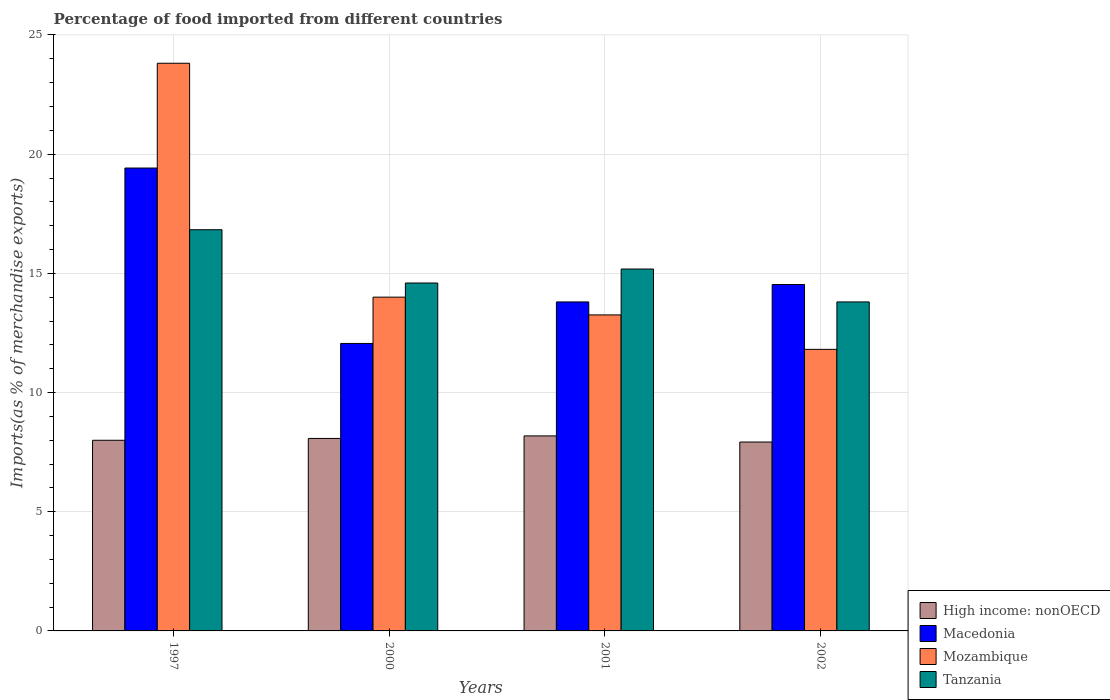How many different coloured bars are there?
Your response must be concise. 4. How many bars are there on the 4th tick from the left?
Provide a succinct answer. 4. How many bars are there on the 1st tick from the right?
Give a very brief answer. 4. In how many cases, is the number of bars for a given year not equal to the number of legend labels?
Keep it short and to the point. 0. What is the percentage of imports to different countries in Tanzania in 2000?
Ensure brevity in your answer.  14.6. Across all years, what is the maximum percentage of imports to different countries in Macedonia?
Your answer should be very brief. 19.42. Across all years, what is the minimum percentage of imports to different countries in Mozambique?
Provide a succinct answer. 11.81. In which year was the percentage of imports to different countries in Tanzania minimum?
Keep it short and to the point. 2002. What is the total percentage of imports to different countries in Tanzania in the graph?
Make the answer very short. 60.41. What is the difference between the percentage of imports to different countries in Tanzania in 2000 and that in 2002?
Make the answer very short. 0.79. What is the difference between the percentage of imports to different countries in Mozambique in 1997 and the percentage of imports to different countries in High income: nonOECD in 2001?
Your answer should be compact. 15.63. What is the average percentage of imports to different countries in Mozambique per year?
Offer a terse response. 15.72. In the year 1997, what is the difference between the percentage of imports to different countries in Macedonia and percentage of imports to different countries in High income: nonOECD?
Ensure brevity in your answer.  11.42. What is the ratio of the percentage of imports to different countries in Tanzania in 2001 to that in 2002?
Ensure brevity in your answer.  1.1. Is the difference between the percentage of imports to different countries in Macedonia in 2000 and 2001 greater than the difference between the percentage of imports to different countries in High income: nonOECD in 2000 and 2001?
Your answer should be very brief. No. What is the difference between the highest and the second highest percentage of imports to different countries in Macedonia?
Your answer should be very brief. 4.89. What is the difference between the highest and the lowest percentage of imports to different countries in Tanzania?
Your answer should be compact. 3.03. In how many years, is the percentage of imports to different countries in High income: nonOECD greater than the average percentage of imports to different countries in High income: nonOECD taken over all years?
Ensure brevity in your answer.  2. Is the sum of the percentage of imports to different countries in Tanzania in 1997 and 2000 greater than the maximum percentage of imports to different countries in Macedonia across all years?
Offer a terse response. Yes. What does the 2nd bar from the left in 2001 represents?
Offer a terse response. Macedonia. What does the 2nd bar from the right in 1997 represents?
Offer a very short reply. Mozambique. Is it the case that in every year, the sum of the percentage of imports to different countries in Tanzania and percentage of imports to different countries in Mozambique is greater than the percentage of imports to different countries in Macedonia?
Offer a very short reply. Yes. How many bars are there?
Give a very brief answer. 16. Are all the bars in the graph horizontal?
Your response must be concise. No. What is the difference between two consecutive major ticks on the Y-axis?
Offer a terse response. 5. Are the values on the major ticks of Y-axis written in scientific E-notation?
Provide a short and direct response. No. Does the graph contain any zero values?
Provide a short and direct response. No. Does the graph contain grids?
Offer a very short reply. Yes. Where does the legend appear in the graph?
Your response must be concise. Bottom right. How many legend labels are there?
Ensure brevity in your answer.  4. What is the title of the graph?
Offer a very short reply. Percentage of food imported from different countries. Does "New Zealand" appear as one of the legend labels in the graph?
Provide a short and direct response. No. What is the label or title of the X-axis?
Give a very brief answer. Years. What is the label or title of the Y-axis?
Offer a terse response. Imports(as % of merchandise exports). What is the Imports(as % of merchandise exports) of High income: nonOECD in 1997?
Give a very brief answer. 8. What is the Imports(as % of merchandise exports) in Macedonia in 1997?
Provide a succinct answer. 19.42. What is the Imports(as % of merchandise exports) of Mozambique in 1997?
Your answer should be very brief. 23.81. What is the Imports(as % of merchandise exports) in Tanzania in 1997?
Provide a short and direct response. 16.83. What is the Imports(as % of merchandise exports) of High income: nonOECD in 2000?
Keep it short and to the point. 8.07. What is the Imports(as % of merchandise exports) of Macedonia in 2000?
Provide a succinct answer. 12.06. What is the Imports(as % of merchandise exports) of Mozambique in 2000?
Offer a very short reply. 14. What is the Imports(as % of merchandise exports) of Tanzania in 2000?
Give a very brief answer. 14.6. What is the Imports(as % of merchandise exports) of High income: nonOECD in 2001?
Keep it short and to the point. 8.18. What is the Imports(as % of merchandise exports) of Macedonia in 2001?
Give a very brief answer. 13.8. What is the Imports(as % of merchandise exports) of Mozambique in 2001?
Provide a short and direct response. 13.26. What is the Imports(as % of merchandise exports) in Tanzania in 2001?
Offer a terse response. 15.18. What is the Imports(as % of merchandise exports) in High income: nonOECD in 2002?
Offer a very short reply. 7.92. What is the Imports(as % of merchandise exports) in Macedonia in 2002?
Offer a very short reply. 14.53. What is the Imports(as % of merchandise exports) in Mozambique in 2002?
Provide a short and direct response. 11.81. What is the Imports(as % of merchandise exports) of Tanzania in 2002?
Your answer should be very brief. 13.8. Across all years, what is the maximum Imports(as % of merchandise exports) in High income: nonOECD?
Make the answer very short. 8.18. Across all years, what is the maximum Imports(as % of merchandise exports) of Macedonia?
Keep it short and to the point. 19.42. Across all years, what is the maximum Imports(as % of merchandise exports) in Mozambique?
Give a very brief answer. 23.81. Across all years, what is the maximum Imports(as % of merchandise exports) of Tanzania?
Provide a succinct answer. 16.83. Across all years, what is the minimum Imports(as % of merchandise exports) in High income: nonOECD?
Make the answer very short. 7.92. Across all years, what is the minimum Imports(as % of merchandise exports) in Macedonia?
Provide a short and direct response. 12.06. Across all years, what is the minimum Imports(as % of merchandise exports) in Mozambique?
Make the answer very short. 11.81. Across all years, what is the minimum Imports(as % of merchandise exports) in Tanzania?
Make the answer very short. 13.8. What is the total Imports(as % of merchandise exports) in High income: nonOECD in the graph?
Your answer should be compact. 32.18. What is the total Imports(as % of merchandise exports) of Macedonia in the graph?
Your response must be concise. 59.81. What is the total Imports(as % of merchandise exports) in Mozambique in the graph?
Your response must be concise. 62.88. What is the total Imports(as % of merchandise exports) of Tanzania in the graph?
Give a very brief answer. 60.41. What is the difference between the Imports(as % of merchandise exports) in High income: nonOECD in 1997 and that in 2000?
Ensure brevity in your answer.  -0.08. What is the difference between the Imports(as % of merchandise exports) of Macedonia in 1997 and that in 2000?
Your answer should be very brief. 7.36. What is the difference between the Imports(as % of merchandise exports) of Mozambique in 1997 and that in 2000?
Provide a succinct answer. 9.81. What is the difference between the Imports(as % of merchandise exports) in Tanzania in 1997 and that in 2000?
Provide a short and direct response. 2.24. What is the difference between the Imports(as % of merchandise exports) of High income: nonOECD in 1997 and that in 2001?
Offer a terse response. -0.18. What is the difference between the Imports(as % of merchandise exports) in Macedonia in 1997 and that in 2001?
Provide a short and direct response. 5.62. What is the difference between the Imports(as % of merchandise exports) in Mozambique in 1997 and that in 2001?
Provide a succinct answer. 10.56. What is the difference between the Imports(as % of merchandise exports) in Tanzania in 1997 and that in 2001?
Give a very brief answer. 1.65. What is the difference between the Imports(as % of merchandise exports) of High income: nonOECD in 1997 and that in 2002?
Your answer should be compact. 0.07. What is the difference between the Imports(as % of merchandise exports) of Macedonia in 1997 and that in 2002?
Keep it short and to the point. 4.89. What is the difference between the Imports(as % of merchandise exports) in Mozambique in 1997 and that in 2002?
Your response must be concise. 12. What is the difference between the Imports(as % of merchandise exports) of Tanzania in 1997 and that in 2002?
Your answer should be compact. 3.03. What is the difference between the Imports(as % of merchandise exports) of High income: nonOECD in 2000 and that in 2001?
Make the answer very short. -0.11. What is the difference between the Imports(as % of merchandise exports) of Macedonia in 2000 and that in 2001?
Your answer should be compact. -1.74. What is the difference between the Imports(as % of merchandise exports) in Mozambique in 2000 and that in 2001?
Provide a succinct answer. 0.75. What is the difference between the Imports(as % of merchandise exports) of Tanzania in 2000 and that in 2001?
Your response must be concise. -0.59. What is the difference between the Imports(as % of merchandise exports) in High income: nonOECD in 2000 and that in 2002?
Your response must be concise. 0.15. What is the difference between the Imports(as % of merchandise exports) of Macedonia in 2000 and that in 2002?
Provide a short and direct response. -2.47. What is the difference between the Imports(as % of merchandise exports) of Mozambique in 2000 and that in 2002?
Keep it short and to the point. 2.19. What is the difference between the Imports(as % of merchandise exports) of Tanzania in 2000 and that in 2002?
Your answer should be very brief. 0.79. What is the difference between the Imports(as % of merchandise exports) in High income: nonOECD in 2001 and that in 2002?
Provide a succinct answer. 0.26. What is the difference between the Imports(as % of merchandise exports) of Macedonia in 2001 and that in 2002?
Your response must be concise. -0.73. What is the difference between the Imports(as % of merchandise exports) in Mozambique in 2001 and that in 2002?
Your answer should be compact. 1.44. What is the difference between the Imports(as % of merchandise exports) of Tanzania in 2001 and that in 2002?
Your answer should be very brief. 1.38. What is the difference between the Imports(as % of merchandise exports) in High income: nonOECD in 1997 and the Imports(as % of merchandise exports) in Macedonia in 2000?
Offer a very short reply. -4.06. What is the difference between the Imports(as % of merchandise exports) of High income: nonOECD in 1997 and the Imports(as % of merchandise exports) of Mozambique in 2000?
Keep it short and to the point. -6. What is the difference between the Imports(as % of merchandise exports) of High income: nonOECD in 1997 and the Imports(as % of merchandise exports) of Tanzania in 2000?
Provide a short and direct response. -6.6. What is the difference between the Imports(as % of merchandise exports) in Macedonia in 1997 and the Imports(as % of merchandise exports) in Mozambique in 2000?
Make the answer very short. 5.42. What is the difference between the Imports(as % of merchandise exports) in Macedonia in 1997 and the Imports(as % of merchandise exports) in Tanzania in 2000?
Keep it short and to the point. 4.82. What is the difference between the Imports(as % of merchandise exports) of Mozambique in 1997 and the Imports(as % of merchandise exports) of Tanzania in 2000?
Offer a very short reply. 9.22. What is the difference between the Imports(as % of merchandise exports) of High income: nonOECD in 1997 and the Imports(as % of merchandise exports) of Macedonia in 2001?
Your answer should be very brief. -5.8. What is the difference between the Imports(as % of merchandise exports) in High income: nonOECD in 1997 and the Imports(as % of merchandise exports) in Mozambique in 2001?
Ensure brevity in your answer.  -5.26. What is the difference between the Imports(as % of merchandise exports) of High income: nonOECD in 1997 and the Imports(as % of merchandise exports) of Tanzania in 2001?
Give a very brief answer. -7.18. What is the difference between the Imports(as % of merchandise exports) of Macedonia in 1997 and the Imports(as % of merchandise exports) of Mozambique in 2001?
Keep it short and to the point. 6.16. What is the difference between the Imports(as % of merchandise exports) in Macedonia in 1997 and the Imports(as % of merchandise exports) in Tanzania in 2001?
Your answer should be very brief. 4.24. What is the difference between the Imports(as % of merchandise exports) of Mozambique in 1997 and the Imports(as % of merchandise exports) of Tanzania in 2001?
Make the answer very short. 8.63. What is the difference between the Imports(as % of merchandise exports) of High income: nonOECD in 1997 and the Imports(as % of merchandise exports) of Macedonia in 2002?
Your answer should be very brief. -6.53. What is the difference between the Imports(as % of merchandise exports) in High income: nonOECD in 1997 and the Imports(as % of merchandise exports) in Mozambique in 2002?
Your answer should be compact. -3.81. What is the difference between the Imports(as % of merchandise exports) of High income: nonOECD in 1997 and the Imports(as % of merchandise exports) of Tanzania in 2002?
Ensure brevity in your answer.  -5.8. What is the difference between the Imports(as % of merchandise exports) of Macedonia in 1997 and the Imports(as % of merchandise exports) of Mozambique in 2002?
Your answer should be very brief. 7.61. What is the difference between the Imports(as % of merchandise exports) of Macedonia in 1997 and the Imports(as % of merchandise exports) of Tanzania in 2002?
Make the answer very short. 5.62. What is the difference between the Imports(as % of merchandise exports) of Mozambique in 1997 and the Imports(as % of merchandise exports) of Tanzania in 2002?
Provide a succinct answer. 10.01. What is the difference between the Imports(as % of merchandise exports) in High income: nonOECD in 2000 and the Imports(as % of merchandise exports) in Macedonia in 2001?
Your answer should be compact. -5.73. What is the difference between the Imports(as % of merchandise exports) of High income: nonOECD in 2000 and the Imports(as % of merchandise exports) of Mozambique in 2001?
Provide a short and direct response. -5.18. What is the difference between the Imports(as % of merchandise exports) of High income: nonOECD in 2000 and the Imports(as % of merchandise exports) of Tanzania in 2001?
Keep it short and to the point. -7.11. What is the difference between the Imports(as % of merchandise exports) of Macedonia in 2000 and the Imports(as % of merchandise exports) of Mozambique in 2001?
Your answer should be very brief. -1.2. What is the difference between the Imports(as % of merchandise exports) of Macedonia in 2000 and the Imports(as % of merchandise exports) of Tanzania in 2001?
Make the answer very short. -3.12. What is the difference between the Imports(as % of merchandise exports) of Mozambique in 2000 and the Imports(as % of merchandise exports) of Tanzania in 2001?
Your answer should be very brief. -1.18. What is the difference between the Imports(as % of merchandise exports) in High income: nonOECD in 2000 and the Imports(as % of merchandise exports) in Macedonia in 2002?
Offer a very short reply. -6.46. What is the difference between the Imports(as % of merchandise exports) of High income: nonOECD in 2000 and the Imports(as % of merchandise exports) of Mozambique in 2002?
Provide a short and direct response. -3.74. What is the difference between the Imports(as % of merchandise exports) in High income: nonOECD in 2000 and the Imports(as % of merchandise exports) in Tanzania in 2002?
Your response must be concise. -5.73. What is the difference between the Imports(as % of merchandise exports) of Macedonia in 2000 and the Imports(as % of merchandise exports) of Mozambique in 2002?
Provide a succinct answer. 0.25. What is the difference between the Imports(as % of merchandise exports) in Macedonia in 2000 and the Imports(as % of merchandise exports) in Tanzania in 2002?
Your answer should be compact. -1.74. What is the difference between the Imports(as % of merchandise exports) of Mozambique in 2000 and the Imports(as % of merchandise exports) of Tanzania in 2002?
Offer a very short reply. 0.2. What is the difference between the Imports(as % of merchandise exports) in High income: nonOECD in 2001 and the Imports(as % of merchandise exports) in Macedonia in 2002?
Give a very brief answer. -6.35. What is the difference between the Imports(as % of merchandise exports) of High income: nonOECD in 2001 and the Imports(as % of merchandise exports) of Mozambique in 2002?
Ensure brevity in your answer.  -3.63. What is the difference between the Imports(as % of merchandise exports) of High income: nonOECD in 2001 and the Imports(as % of merchandise exports) of Tanzania in 2002?
Give a very brief answer. -5.62. What is the difference between the Imports(as % of merchandise exports) in Macedonia in 2001 and the Imports(as % of merchandise exports) in Mozambique in 2002?
Ensure brevity in your answer.  1.99. What is the difference between the Imports(as % of merchandise exports) in Macedonia in 2001 and the Imports(as % of merchandise exports) in Tanzania in 2002?
Your response must be concise. -0. What is the difference between the Imports(as % of merchandise exports) of Mozambique in 2001 and the Imports(as % of merchandise exports) of Tanzania in 2002?
Provide a short and direct response. -0.55. What is the average Imports(as % of merchandise exports) in High income: nonOECD per year?
Give a very brief answer. 8.04. What is the average Imports(as % of merchandise exports) of Macedonia per year?
Offer a very short reply. 14.95. What is the average Imports(as % of merchandise exports) of Mozambique per year?
Offer a very short reply. 15.72. What is the average Imports(as % of merchandise exports) in Tanzania per year?
Keep it short and to the point. 15.1. In the year 1997, what is the difference between the Imports(as % of merchandise exports) in High income: nonOECD and Imports(as % of merchandise exports) in Macedonia?
Give a very brief answer. -11.42. In the year 1997, what is the difference between the Imports(as % of merchandise exports) of High income: nonOECD and Imports(as % of merchandise exports) of Mozambique?
Offer a very short reply. -15.82. In the year 1997, what is the difference between the Imports(as % of merchandise exports) in High income: nonOECD and Imports(as % of merchandise exports) in Tanzania?
Provide a succinct answer. -8.83. In the year 1997, what is the difference between the Imports(as % of merchandise exports) of Macedonia and Imports(as % of merchandise exports) of Mozambique?
Your answer should be compact. -4.4. In the year 1997, what is the difference between the Imports(as % of merchandise exports) of Macedonia and Imports(as % of merchandise exports) of Tanzania?
Your response must be concise. 2.59. In the year 1997, what is the difference between the Imports(as % of merchandise exports) in Mozambique and Imports(as % of merchandise exports) in Tanzania?
Provide a short and direct response. 6.98. In the year 2000, what is the difference between the Imports(as % of merchandise exports) of High income: nonOECD and Imports(as % of merchandise exports) of Macedonia?
Offer a terse response. -3.98. In the year 2000, what is the difference between the Imports(as % of merchandise exports) in High income: nonOECD and Imports(as % of merchandise exports) in Mozambique?
Provide a short and direct response. -5.93. In the year 2000, what is the difference between the Imports(as % of merchandise exports) in High income: nonOECD and Imports(as % of merchandise exports) in Tanzania?
Provide a succinct answer. -6.52. In the year 2000, what is the difference between the Imports(as % of merchandise exports) in Macedonia and Imports(as % of merchandise exports) in Mozambique?
Give a very brief answer. -1.94. In the year 2000, what is the difference between the Imports(as % of merchandise exports) of Macedonia and Imports(as % of merchandise exports) of Tanzania?
Provide a succinct answer. -2.54. In the year 2000, what is the difference between the Imports(as % of merchandise exports) of Mozambique and Imports(as % of merchandise exports) of Tanzania?
Keep it short and to the point. -0.59. In the year 2001, what is the difference between the Imports(as % of merchandise exports) of High income: nonOECD and Imports(as % of merchandise exports) of Macedonia?
Offer a very short reply. -5.62. In the year 2001, what is the difference between the Imports(as % of merchandise exports) in High income: nonOECD and Imports(as % of merchandise exports) in Mozambique?
Give a very brief answer. -5.08. In the year 2001, what is the difference between the Imports(as % of merchandise exports) of High income: nonOECD and Imports(as % of merchandise exports) of Tanzania?
Keep it short and to the point. -7. In the year 2001, what is the difference between the Imports(as % of merchandise exports) of Macedonia and Imports(as % of merchandise exports) of Mozambique?
Offer a terse response. 0.54. In the year 2001, what is the difference between the Imports(as % of merchandise exports) of Macedonia and Imports(as % of merchandise exports) of Tanzania?
Offer a very short reply. -1.38. In the year 2001, what is the difference between the Imports(as % of merchandise exports) of Mozambique and Imports(as % of merchandise exports) of Tanzania?
Make the answer very short. -1.93. In the year 2002, what is the difference between the Imports(as % of merchandise exports) of High income: nonOECD and Imports(as % of merchandise exports) of Macedonia?
Keep it short and to the point. -6.61. In the year 2002, what is the difference between the Imports(as % of merchandise exports) in High income: nonOECD and Imports(as % of merchandise exports) in Mozambique?
Provide a short and direct response. -3.89. In the year 2002, what is the difference between the Imports(as % of merchandise exports) of High income: nonOECD and Imports(as % of merchandise exports) of Tanzania?
Provide a succinct answer. -5.88. In the year 2002, what is the difference between the Imports(as % of merchandise exports) in Macedonia and Imports(as % of merchandise exports) in Mozambique?
Your answer should be very brief. 2.72. In the year 2002, what is the difference between the Imports(as % of merchandise exports) in Macedonia and Imports(as % of merchandise exports) in Tanzania?
Ensure brevity in your answer.  0.73. In the year 2002, what is the difference between the Imports(as % of merchandise exports) in Mozambique and Imports(as % of merchandise exports) in Tanzania?
Give a very brief answer. -1.99. What is the ratio of the Imports(as % of merchandise exports) of Macedonia in 1997 to that in 2000?
Your response must be concise. 1.61. What is the ratio of the Imports(as % of merchandise exports) in Mozambique in 1997 to that in 2000?
Provide a succinct answer. 1.7. What is the ratio of the Imports(as % of merchandise exports) of Tanzania in 1997 to that in 2000?
Your answer should be very brief. 1.15. What is the ratio of the Imports(as % of merchandise exports) of High income: nonOECD in 1997 to that in 2001?
Give a very brief answer. 0.98. What is the ratio of the Imports(as % of merchandise exports) of Macedonia in 1997 to that in 2001?
Offer a very short reply. 1.41. What is the ratio of the Imports(as % of merchandise exports) of Mozambique in 1997 to that in 2001?
Your response must be concise. 1.8. What is the ratio of the Imports(as % of merchandise exports) in Tanzania in 1997 to that in 2001?
Offer a terse response. 1.11. What is the ratio of the Imports(as % of merchandise exports) of High income: nonOECD in 1997 to that in 2002?
Your response must be concise. 1.01. What is the ratio of the Imports(as % of merchandise exports) of Macedonia in 1997 to that in 2002?
Make the answer very short. 1.34. What is the ratio of the Imports(as % of merchandise exports) in Mozambique in 1997 to that in 2002?
Make the answer very short. 2.02. What is the ratio of the Imports(as % of merchandise exports) of Tanzania in 1997 to that in 2002?
Your answer should be compact. 1.22. What is the ratio of the Imports(as % of merchandise exports) of High income: nonOECD in 2000 to that in 2001?
Make the answer very short. 0.99. What is the ratio of the Imports(as % of merchandise exports) of Macedonia in 2000 to that in 2001?
Ensure brevity in your answer.  0.87. What is the ratio of the Imports(as % of merchandise exports) of Mozambique in 2000 to that in 2001?
Your answer should be compact. 1.06. What is the ratio of the Imports(as % of merchandise exports) of Tanzania in 2000 to that in 2001?
Provide a succinct answer. 0.96. What is the ratio of the Imports(as % of merchandise exports) in High income: nonOECD in 2000 to that in 2002?
Ensure brevity in your answer.  1.02. What is the ratio of the Imports(as % of merchandise exports) of Macedonia in 2000 to that in 2002?
Keep it short and to the point. 0.83. What is the ratio of the Imports(as % of merchandise exports) of Mozambique in 2000 to that in 2002?
Offer a very short reply. 1.19. What is the ratio of the Imports(as % of merchandise exports) of Tanzania in 2000 to that in 2002?
Offer a very short reply. 1.06. What is the ratio of the Imports(as % of merchandise exports) of High income: nonOECD in 2001 to that in 2002?
Provide a succinct answer. 1.03. What is the ratio of the Imports(as % of merchandise exports) of Macedonia in 2001 to that in 2002?
Keep it short and to the point. 0.95. What is the ratio of the Imports(as % of merchandise exports) in Mozambique in 2001 to that in 2002?
Offer a very short reply. 1.12. What is the difference between the highest and the second highest Imports(as % of merchandise exports) of High income: nonOECD?
Your answer should be very brief. 0.11. What is the difference between the highest and the second highest Imports(as % of merchandise exports) of Macedonia?
Offer a very short reply. 4.89. What is the difference between the highest and the second highest Imports(as % of merchandise exports) of Mozambique?
Your answer should be compact. 9.81. What is the difference between the highest and the second highest Imports(as % of merchandise exports) in Tanzania?
Provide a short and direct response. 1.65. What is the difference between the highest and the lowest Imports(as % of merchandise exports) in High income: nonOECD?
Your response must be concise. 0.26. What is the difference between the highest and the lowest Imports(as % of merchandise exports) of Macedonia?
Your response must be concise. 7.36. What is the difference between the highest and the lowest Imports(as % of merchandise exports) in Mozambique?
Offer a terse response. 12. What is the difference between the highest and the lowest Imports(as % of merchandise exports) in Tanzania?
Give a very brief answer. 3.03. 